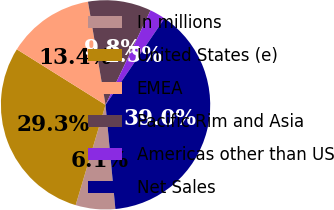<chart> <loc_0><loc_0><loc_500><loc_500><pie_chart><fcel>In millions<fcel>United States (e)<fcel>EMEA<fcel>Pacific Rim and Asia<fcel>Americas other than US<fcel>Net Sales<nl><fcel>6.11%<fcel>29.29%<fcel>13.41%<fcel>9.76%<fcel>2.45%<fcel>38.98%<nl></chart> 